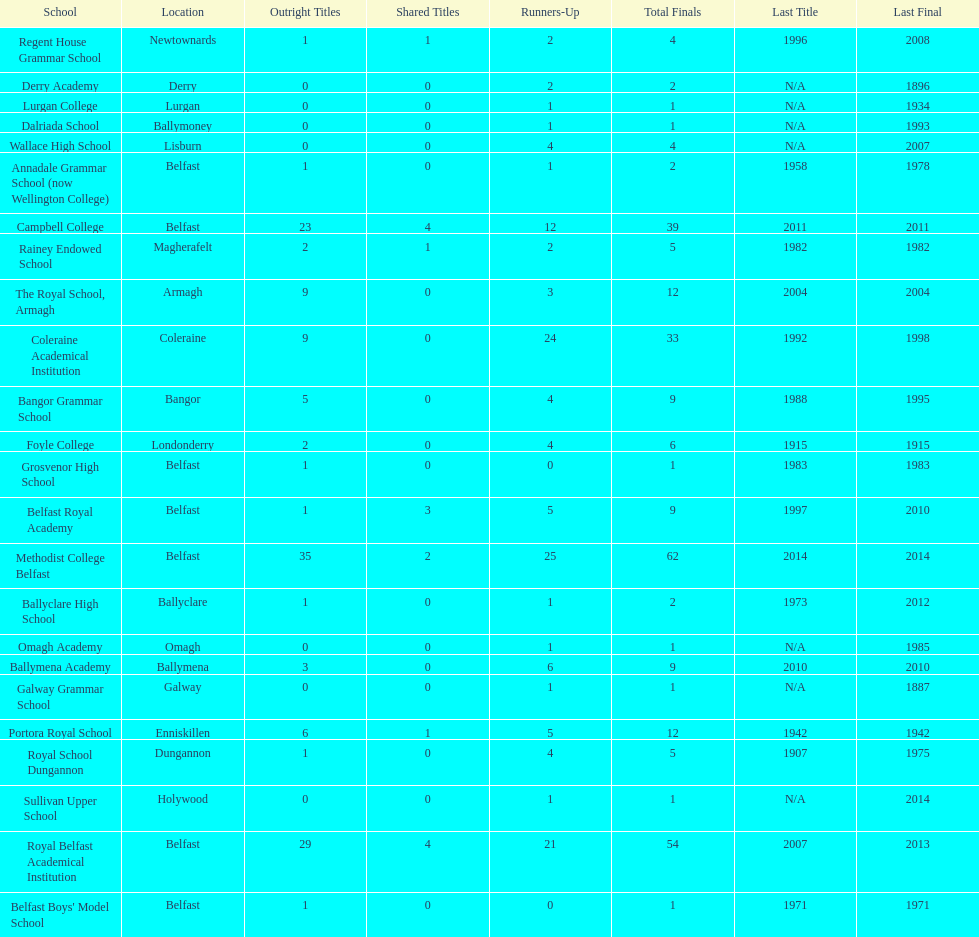What is the difference in runners-up from coleraine academical institution and royal school dungannon? 20. 